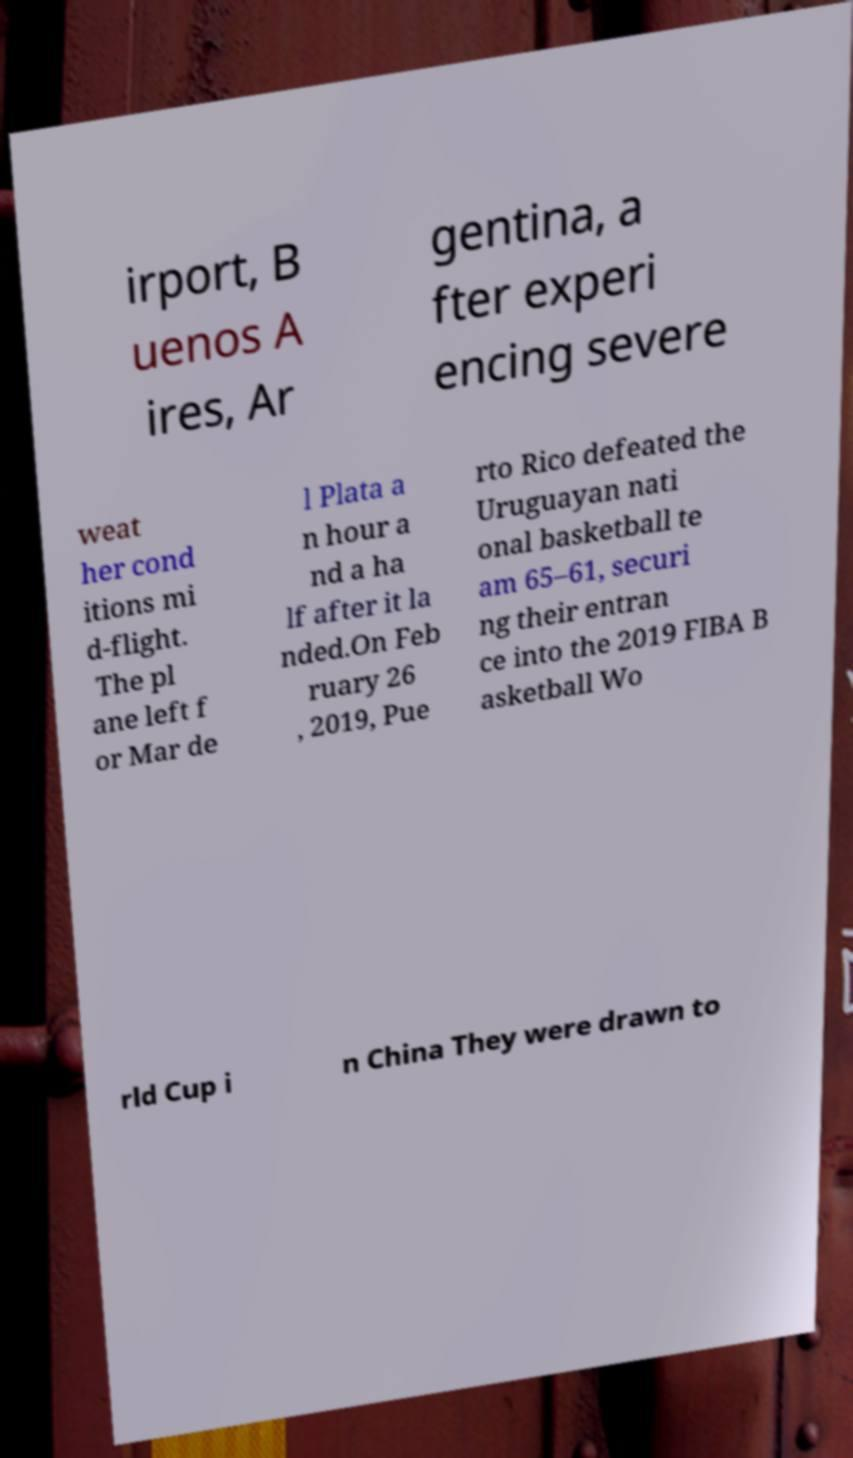There's text embedded in this image that I need extracted. Can you transcribe it verbatim? irport, B uenos A ires, Ar gentina, a fter experi encing severe weat her cond itions mi d-flight. The pl ane left f or Mar de l Plata a n hour a nd a ha lf after it la nded.On Feb ruary 26 , 2019, Pue rto Rico defeated the Uruguayan nati onal basketball te am 65–61, securi ng their entran ce into the 2019 FIBA B asketball Wo rld Cup i n China They were drawn to 